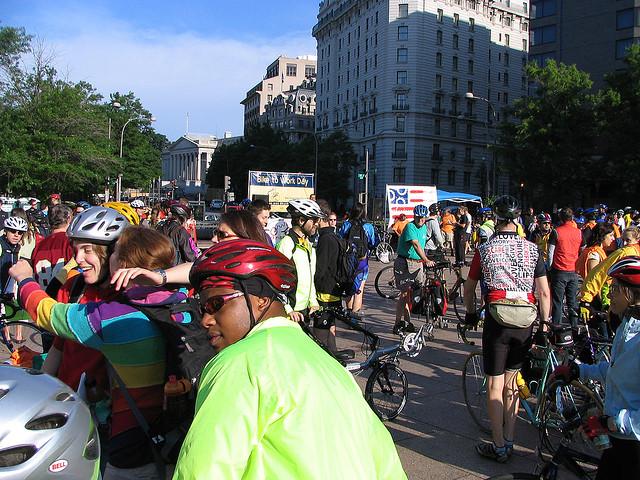Who are they?
Give a very brief answer. Bikers. How many floors are in the front building of the image?
Keep it brief. 8. What are they riding?
Give a very brief answer. Bicycles. 